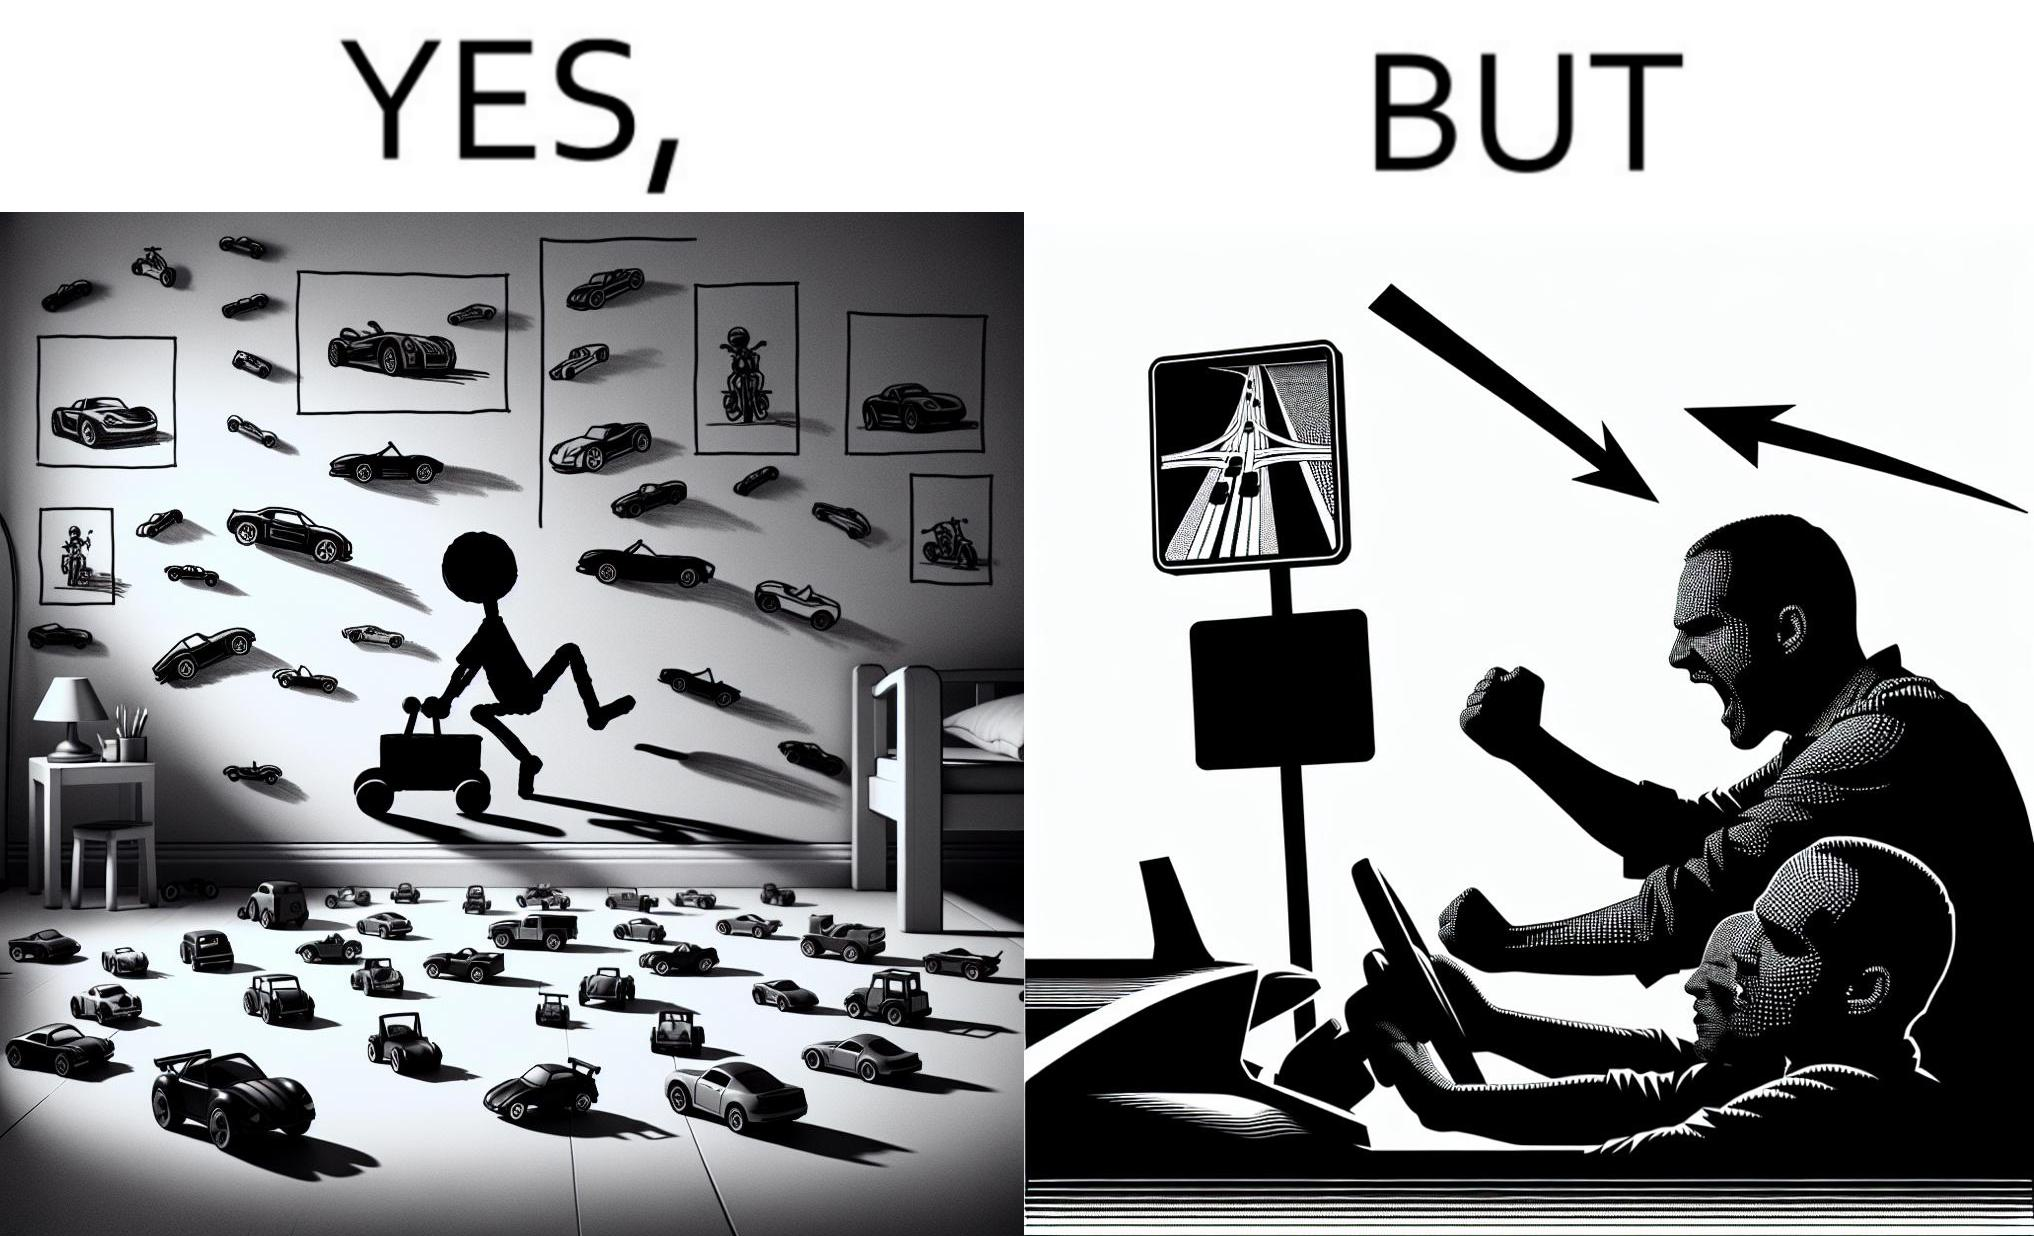Explain the humor or irony in this image. The image is funny beaucse while the person as a child enjoyed being around cars, had various small toy cars and even rode a bigger toy car, as as grown up he does not enjoy being in a car during a traffic jam while he is driving . 